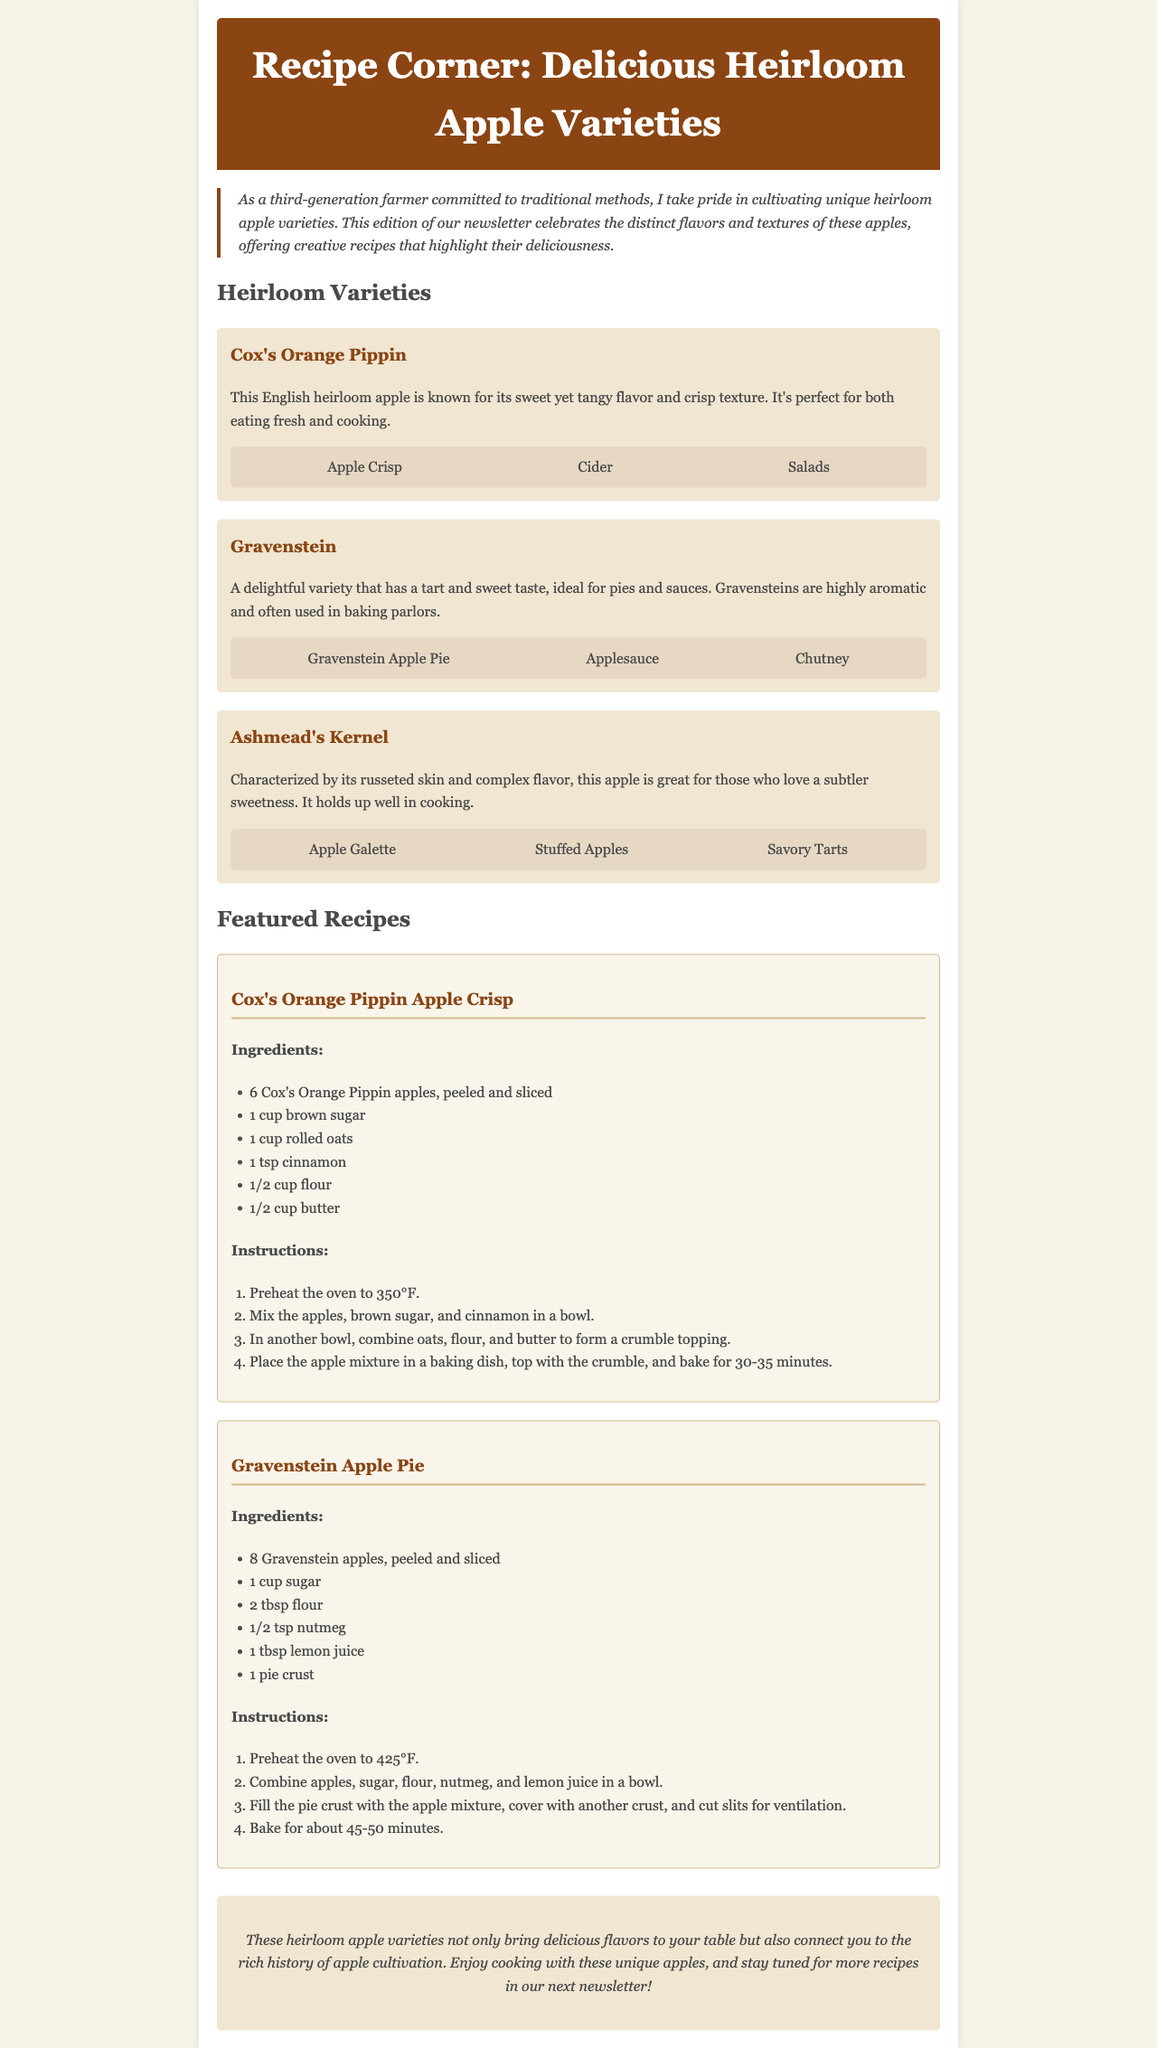What is the primary focus of the newsletter? The newsletter focuses on celebrating heirloom apple varieties and providing creative recipes using them.
Answer: Heirloom apple varieties How many heirloom apple varieties are mentioned? The document mentions three distinct heirloom apple varieties listed in the 'Heirloom Varieties' section.
Answer: Three What recipe features Cox's Orange Pippin apples? The recipe that features Cox's Orange Pippin apples is listed under 'Featured Recipes' in the document.
Answer: Cox's Orange Pippin Apple Crisp What is the baking temperature for the Gravenstein Apple Pie? The required baking temperature for the Gravenstein Apple Pie is stated clearly in the recipe instructions included in the document.
Answer: 425°F What type of apple is characterized by russeted skin? This information is provided in the description of Ashmead's Kernel, highlighting its distinct features in the document.
Answer: Ashmead's Kernel What ingredient is used for the crumble topping in the Cox's Orange Pippin Apple Crisp? The crumble topping's ingredients include oats, flour, and butter, specifically noted in its recipe.
Answer: Oats How long should the Gravenstein Apple Pie bake? The document specifies the time needed for baking the Gravenstein Apple Pie in the recipe instructions.
Answer: 45-50 minutes What style of cooking does the newsletter promote? The document emphasizes traditional methods of cooking with heirloom apple varieties, aligning with the persona of the farmer.
Answer: Traditional methods 